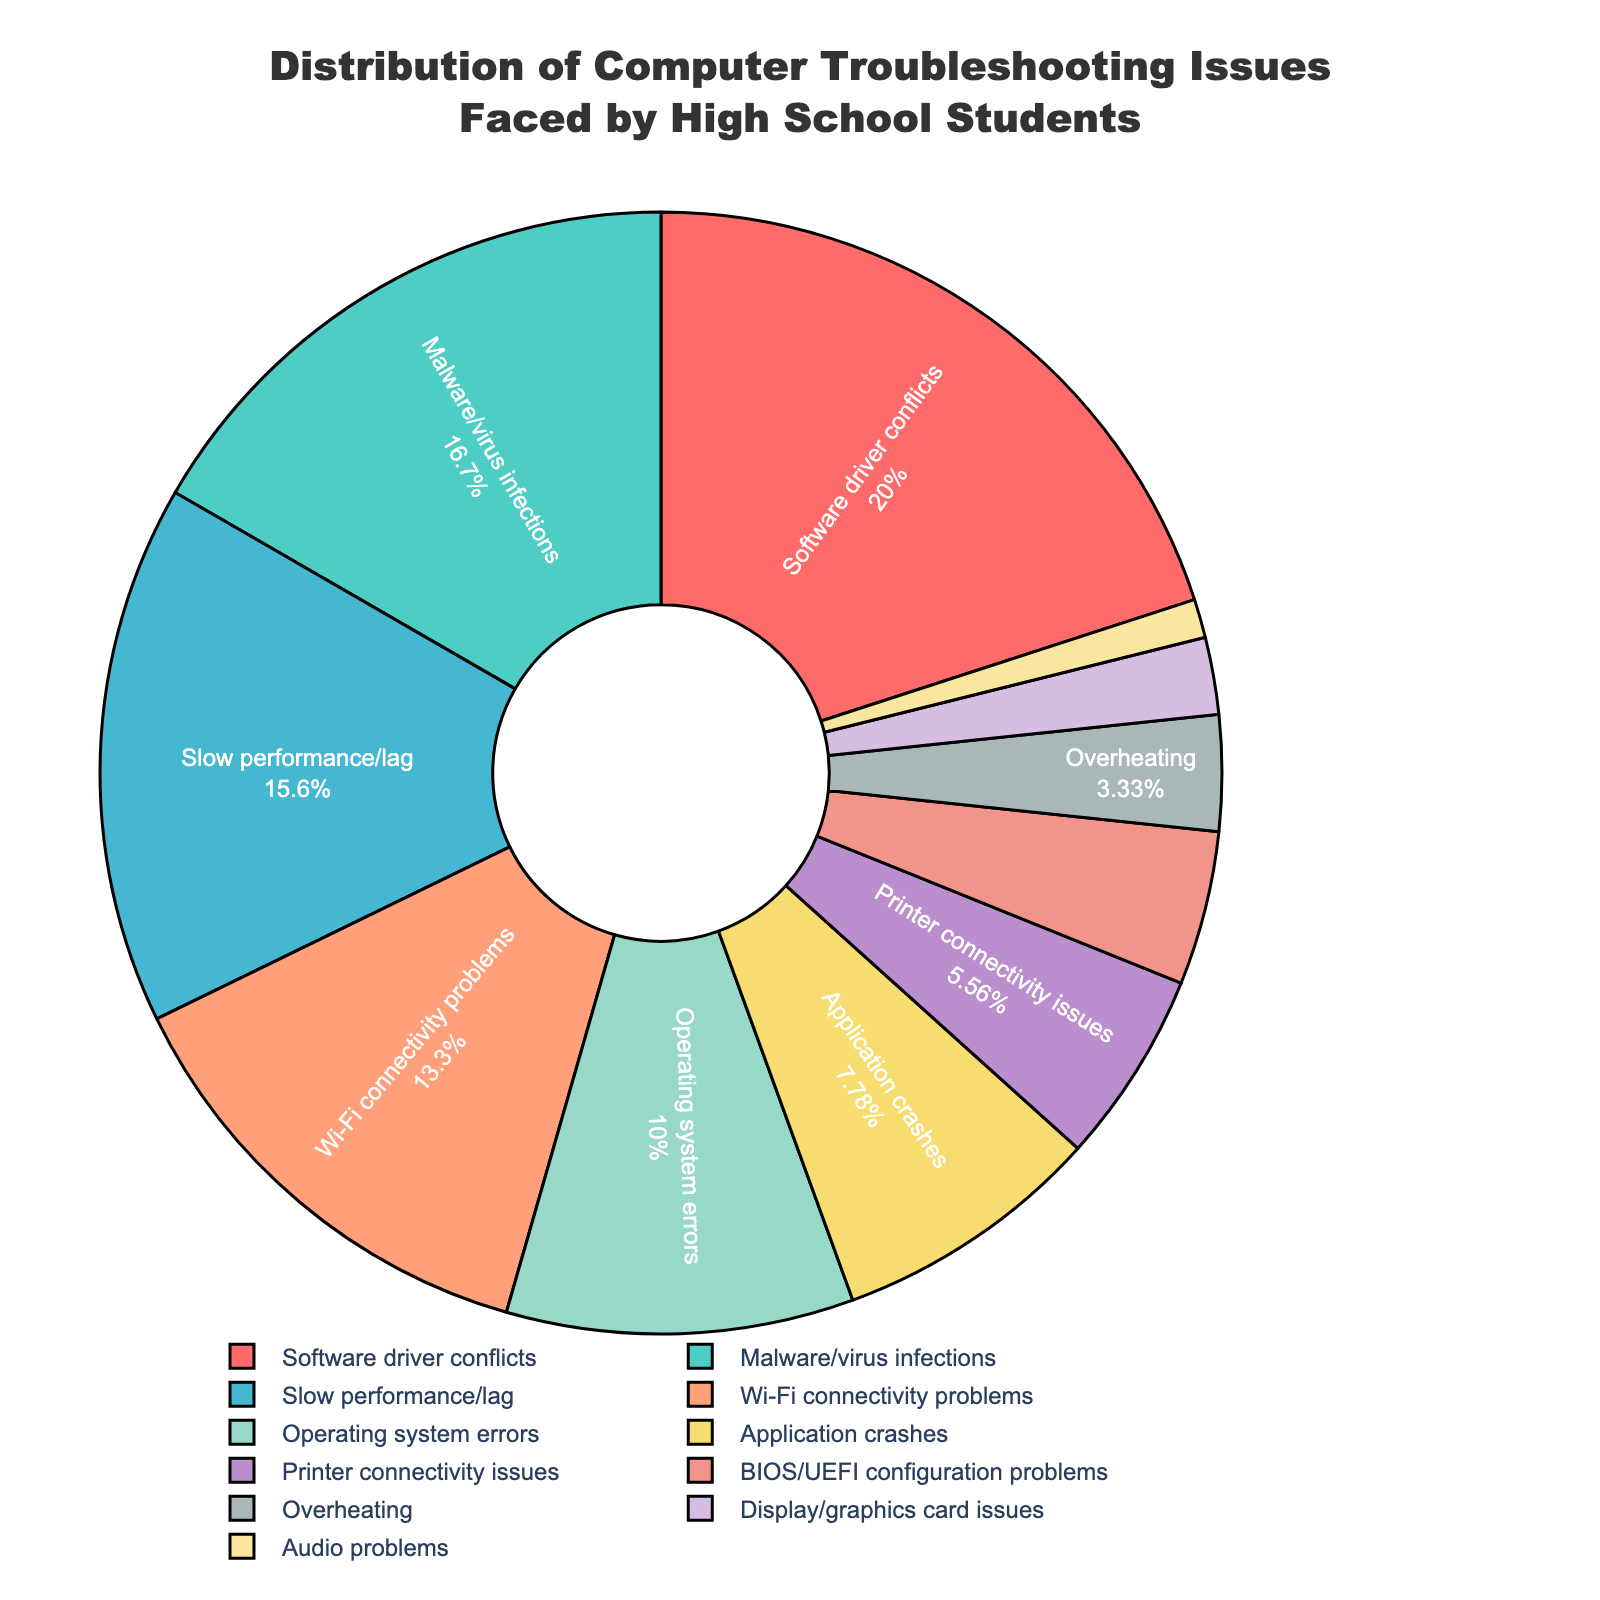What's the most common computer troubleshooting issue faced by high school students? The largest segment in the pie chart represents the most common issue. By observing the chart, we find that "Software driver conflicts" has the largest portion when compared to other issues.
Answer: Software driver conflicts How many percentage points more do "Software driver conflicts" have compared to "Slow performance/lag"? "Software driver conflicts" have 18%, while "Slow performance/lag" has 14%. Subtracting these gives 18% - 14% = 4%.
Answer: 4% Which issue is represented by the smallest portion of the pie chart? The smallest segment in the pie chart is for "Audio problems". The percentage assigned to this segment is 1%, which is less than any other issue present.
Answer: Audio problems What is the combined percentage of "Malware/virus infections" and "Wi-Fi connectivity problems"? "Malware/virus infections" account for 15% and "Wi-Fi connectivity problems" account for 12%. Adding these percentages gives 15% + 12% = 27%.
Answer: 27% Which issue is more common: "Application crashes" or "Operating system errors"? Comparing the portions of "Application crashes" and "Operating system errors" in the pie chart, we see that "Operating system errors" is larger with 9%, while "Application crashes" has 7%.
Answer: Operating system errors How does the percentage of "Printer connectivity issues" compare to that of "Overheating"? "Printer connectivity issues" and "Overheating" can be compared by their size in the pie chart. "Printer connectivity issues" stands at 5% while "Overheating" is at 3%, making the former larger by 2%.
Answer: Printer connectivity issues What is the total percentage of issues related to hardware (i.e., Display/graphics card issues, Audio problems, Overheating, BIOS/UEFI configuration problems)? Adding the hardware-related issues: Display/graphics card (2%), Audio problems (1%), Overheating (3%), BIOS/UEFI configuration problems (4%) sums to 2% + 1% + 3% + 4% = 10%.
Answer: 10% Which issue is associated with the color red in the pie chart? The color red in the pie chart corresponds to "Software driver conflicts". It is the largest segment and is visually identified by the color.
Answer: Software driver conflicts Are "Malware/virus infections" and "Slow performance/lag" almost equally common? "Malware/virus infections" is 15%, and "Slow performance/lag" is 14%. The difference between them is 15% - 14% = 1%, so they are almost equally common.
Answer: Yes What is the approximate average percentage of the top three most common issues? The top three issues and their percentages are "Software driver conflicts" (18%), "Malware/virus infections" (15%), "Slow performance/lag" (14%). The average is (18% + 15% + 14%) / 3 = 47% / 3 ≈ 15.67%.
Answer: 15.67% 